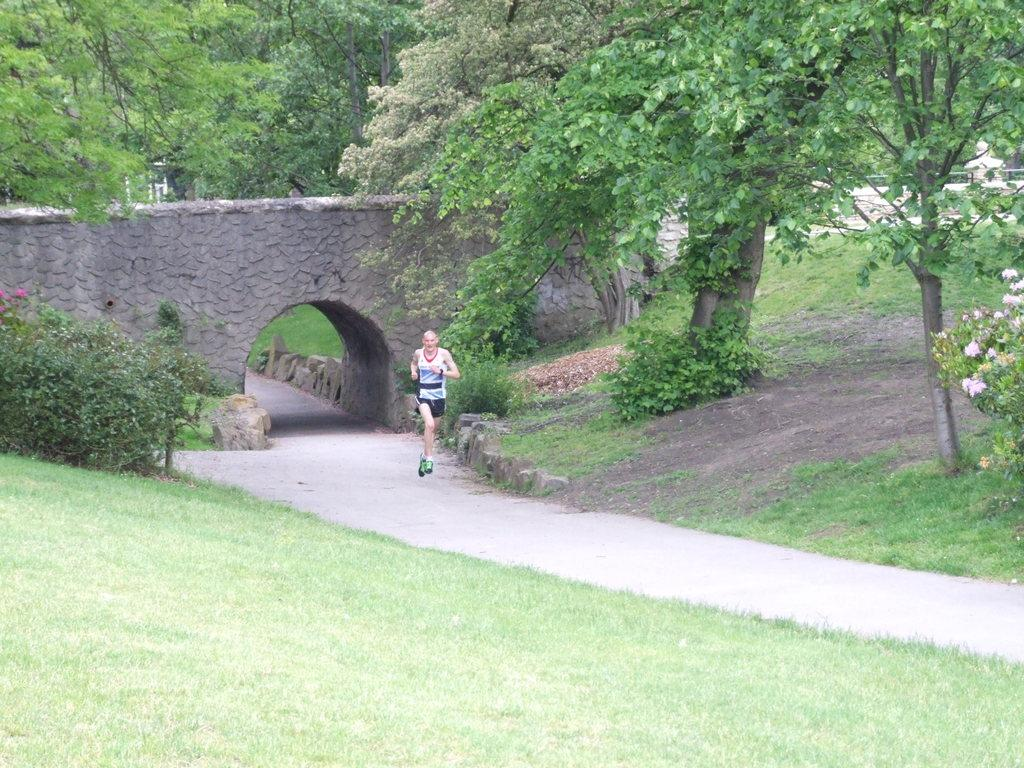Who is the main subject in the image? There is a man in the image. What is the man doing in the image? The man is running in the image. Where is the man running? The man is running on a path in the image. What type of natural environment can be seen in the image? Trees and grass are visible in the image. What type of paper is the man carrying while running in the image? There is no paper visible in the image; the man is running without any visible objects in his hands. 